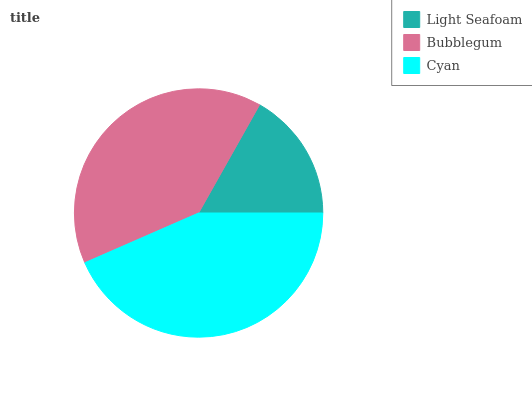Is Light Seafoam the minimum?
Answer yes or no. Yes. Is Cyan the maximum?
Answer yes or no. Yes. Is Bubblegum the minimum?
Answer yes or no. No. Is Bubblegum the maximum?
Answer yes or no. No. Is Bubblegum greater than Light Seafoam?
Answer yes or no. Yes. Is Light Seafoam less than Bubblegum?
Answer yes or no. Yes. Is Light Seafoam greater than Bubblegum?
Answer yes or no. No. Is Bubblegum less than Light Seafoam?
Answer yes or no. No. Is Bubblegum the high median?
Answer yes or no. Yes. Is Bubblegum the low median?
Answer yes or no. Yes. Is Light Seafoam the high median?
Answer yes or no. No. Is Light Seafoam the low median?
Answer yes or no. No. 